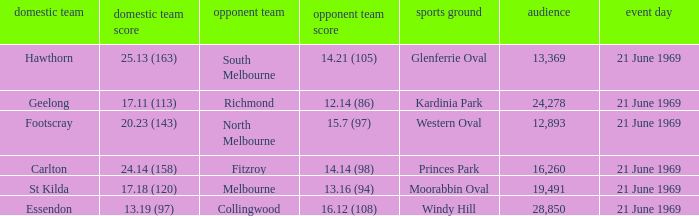What is Essendon's home team that has an away crowd size larger than 19,491? Collingwood. Can you give me this table as a dict? {'header': ['domestic team', 'domestic team score', 'opponent team', 'opponent team score', 'sports ground', 'audience', 'event day'], 'rows': [['Hawthorn', '25.13 (163)', 'South Melbourne', '14.21 (105)', 'Glenferrie Oval', '13,369', '21 June 1969'], ['Geelong', '17.11 (113)', 'Richmond', '12.14 (86)', 'Kardinia Park', '24,278', '21 June 1969'], ['Footscray', '20.23 (143)', 'North Melbourne', '15.7 (97)', 'Western Oval', '12,893', '21 June 1969'], ['Carlton', '24.14 (158)', 'Fitzroy', '14.14 (98)', 'Princes Park', '16,260', '21 June 1969'], ['St Kilda', '17.18 (120)', 'Melbourne', '13.16 (94)', 'Moorabbin Oval', '19,491', '21 June 1969'], ['Essendon', '13.19 (97)', 'Collingwood', '16.12 (108)', 'Windy Hill', '28,850', '21 June 1969']]} 